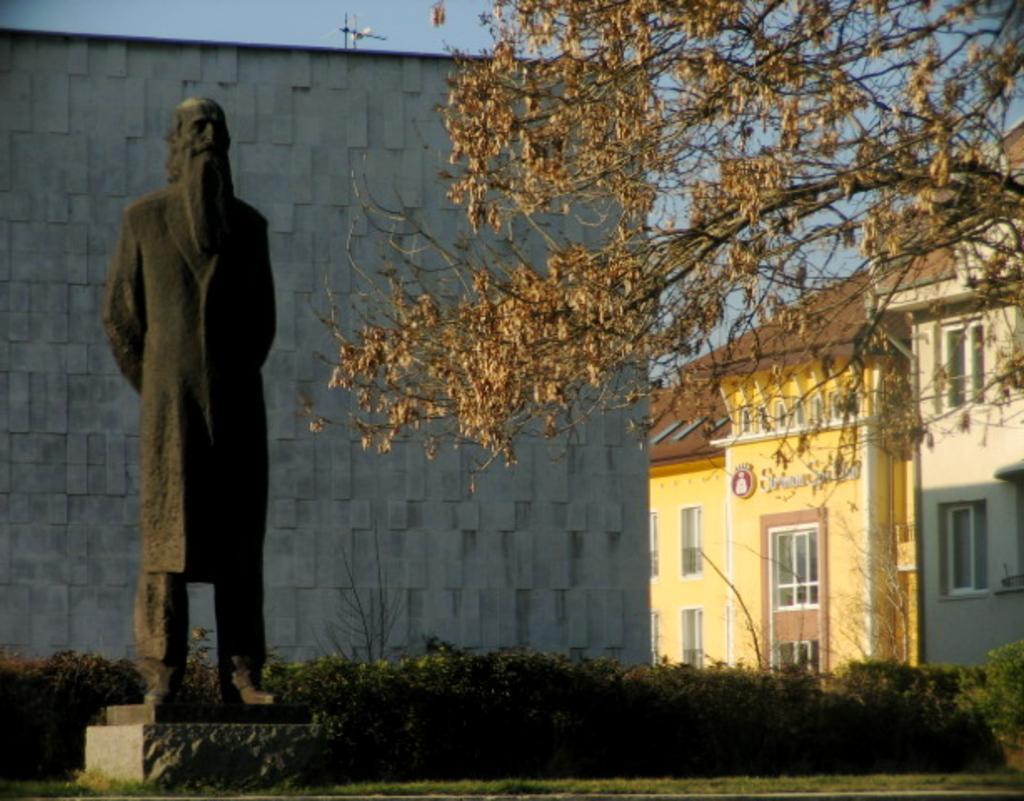Please provide a concise description of this image. At the bottom of the image there is a statue of a person on the pedestal. On the ground there is grass. Behind the statue there are plants. In the background there are buildings with walls, windows, doors and roofs. On the right side of the image there are branches with leaves. 